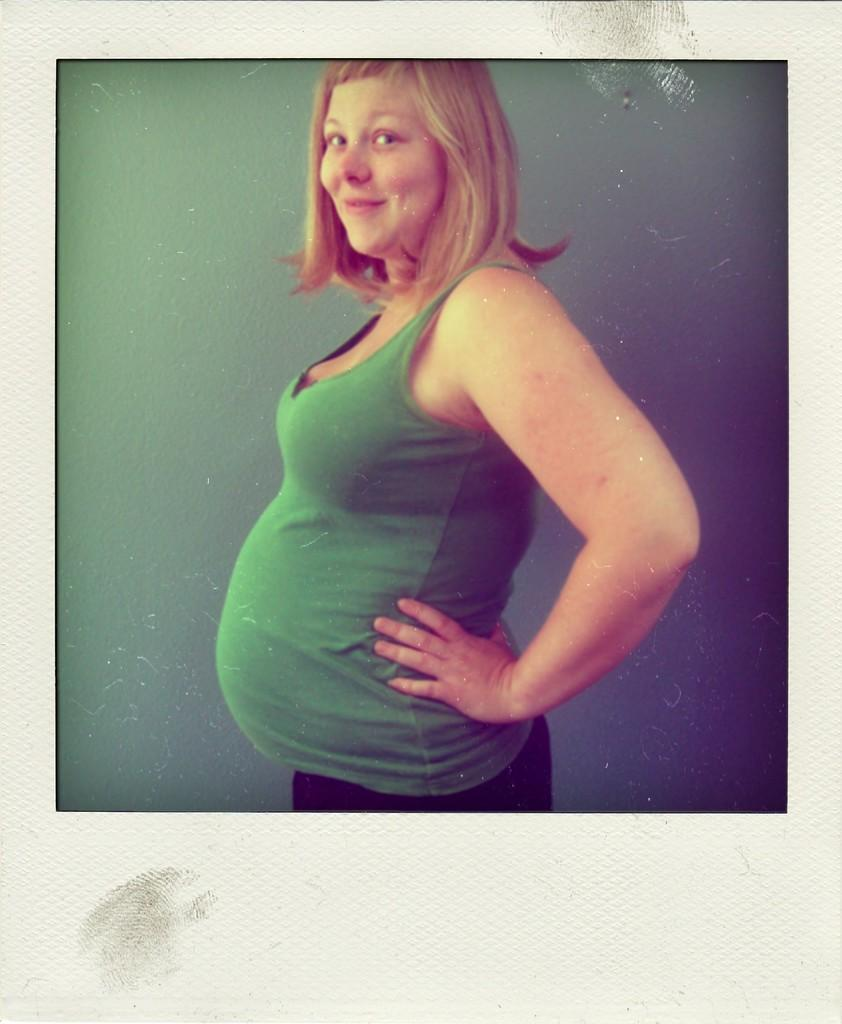What is the main subject of the photo? There is a lady in the photo. Can you describe the background in the photo? There is a background visible in the photo. What type of lace can be seen on the lady's dress in the photo? There is no information about the lady's dress or any lace in the photo. How many flowers are present in the background of the photo? There is no information about flowers or any other specific details about the background in the photo. 